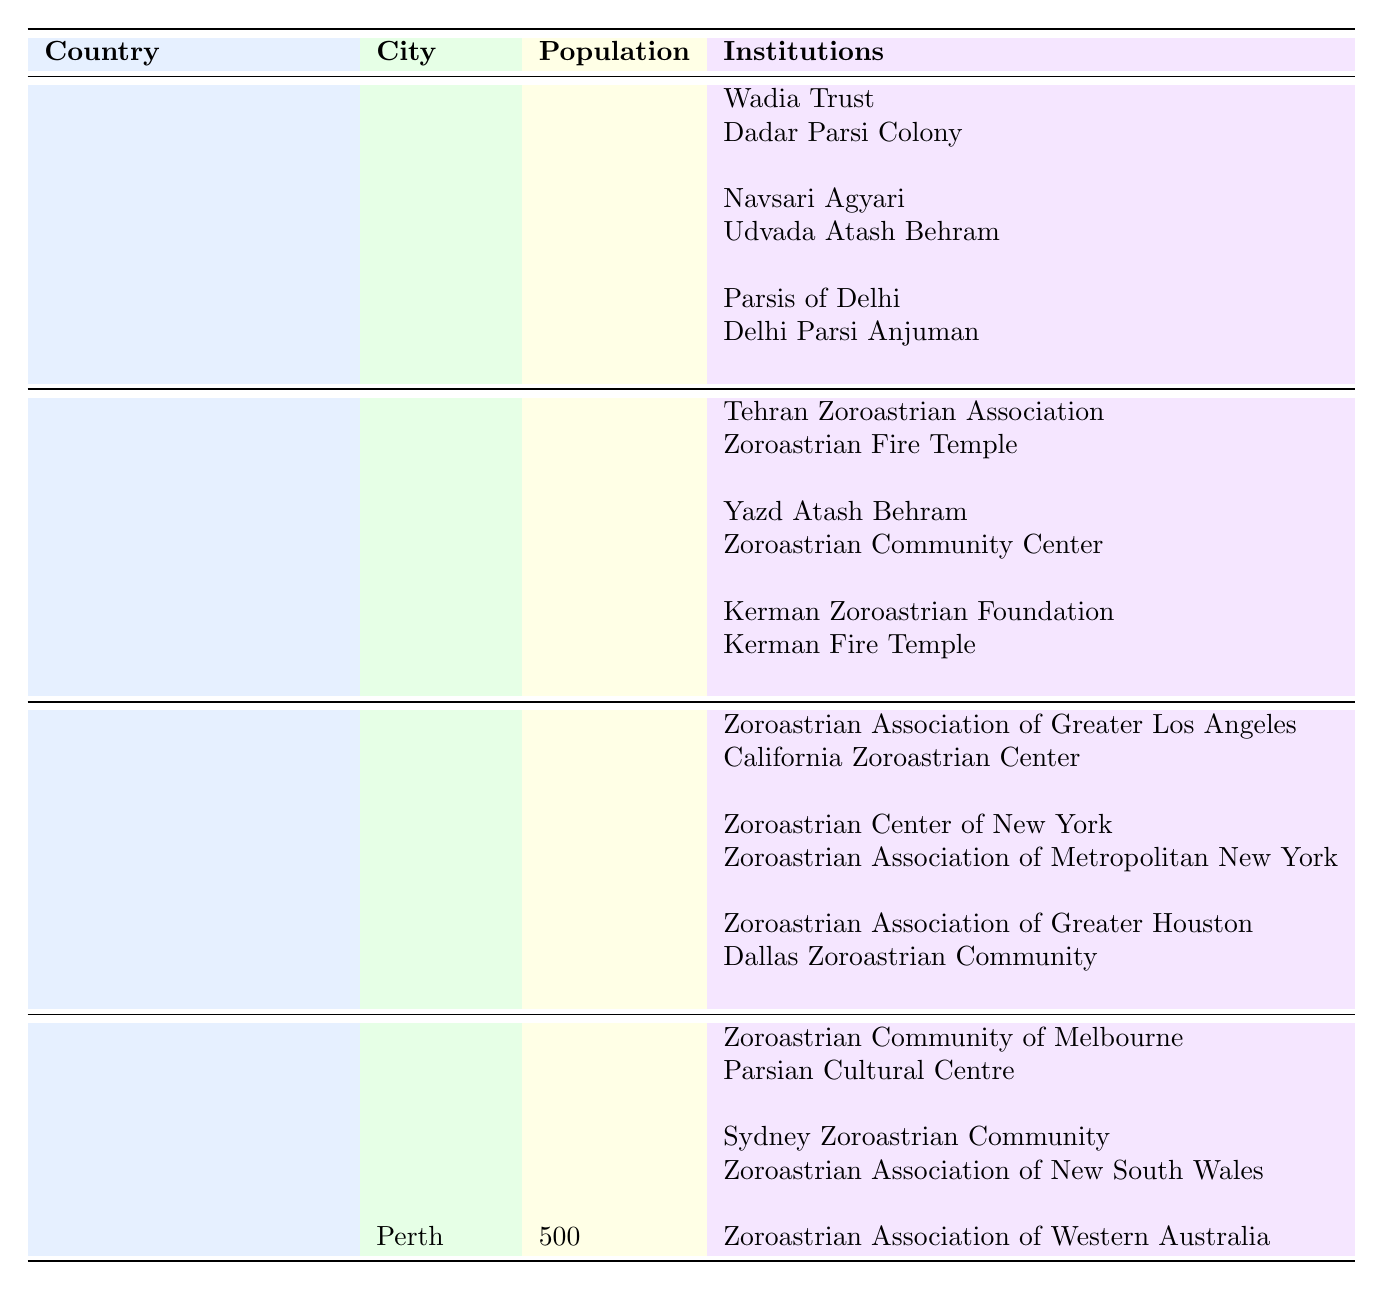What is the total population of Zoroastrian communities in India? The table indicates that the total population of Zoroastrian communities in India is 60,000, as stated in the header for the India section.
Answer: 60,000 Which city has the highest Zoroastrian population in India? In India, Mumbai has the highest population of 25,000, as shown in the respective row under India.
Answer: Mumbai How many institutions are listed for the Yazd community in Iran? The Yazd community in Iran has 2 institutions listed: Yazd Atash Behram and Zoroastrian Community Center. This is verified by looking at the corresponding row for Yazd.
Answer: 2 What is the total population of Zoroastrians in the United States? The table shows that the total population of Zoroastrians in the United States is 20,000, as indicated near the top of the US section.
Answer: 20,000 Is there a Zoroastrian community in Perth, Australia? Yes, there is a Zoroastrian community in Perth, Australia, as indicated in the table under Australia with the information on the institution there.
Answer: Yes Which country has the second-largest Zoroastrian community after India? Based on the populations listed in the table, Iran has the second-largest community with a population of 30,000. India is the largest with 60,000.
Answer: Iran Which institution is associated with the Zoroastrian community in California? The Zoroastrian Association of Greater Los Angeles and California Zoroastrian Center are the institutions listed for California's Zoroastrian community, as shown in the respective row.
Answer: Zoroastrian Association of Greater Los Angeles, California Zoroastrian Center What is the combined population of Zoroastrians in Australia? The total population of Zoroastrians in Australia is 5,000, as stated in the header of the Australia section.
Answer: 5,000 Which city has a population of 5,000 Zoroastrians in Iran? Kerman is the city in Iran that has a population of 5,000 Zoroastrians, confirmed by the respective row in the table.
Answer: Kerman What is the total number of institutions listed for Zoroastrian communities in India? India has a total of 8 institutions listed across its communities: 2 in Mumbai, 2 in Gujarat, and 2 in Delhi, totaling to 8.
Answer: 8 